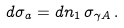Convert formula to latex. <formula><loc_0><loc_0><loc_500><loc_500>d \sigma _ { a } = d n _ { 1 } \, \sigma _ { \gamma A } \, .</formula> 